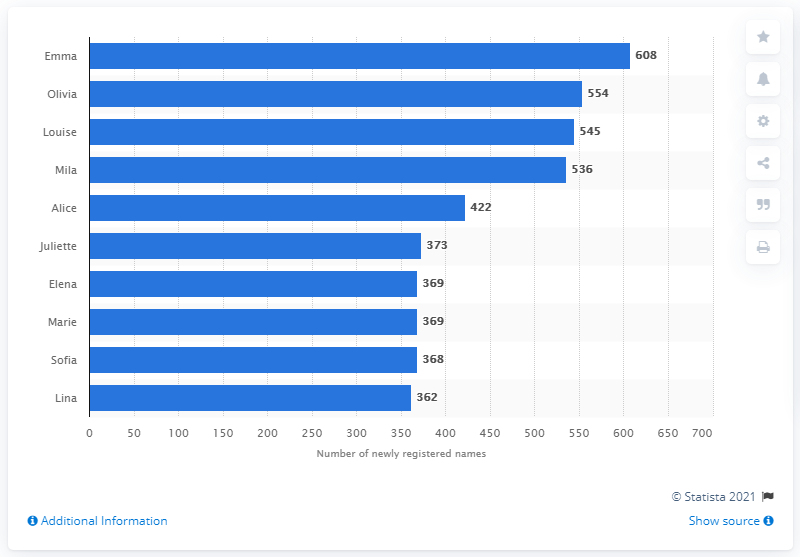Mention a couple of crucial points in this snapshot. The fifth most popular name in Belgium in 2018 was Alice. In 2018, a total of 608 baby girls were registered in Belgium. 